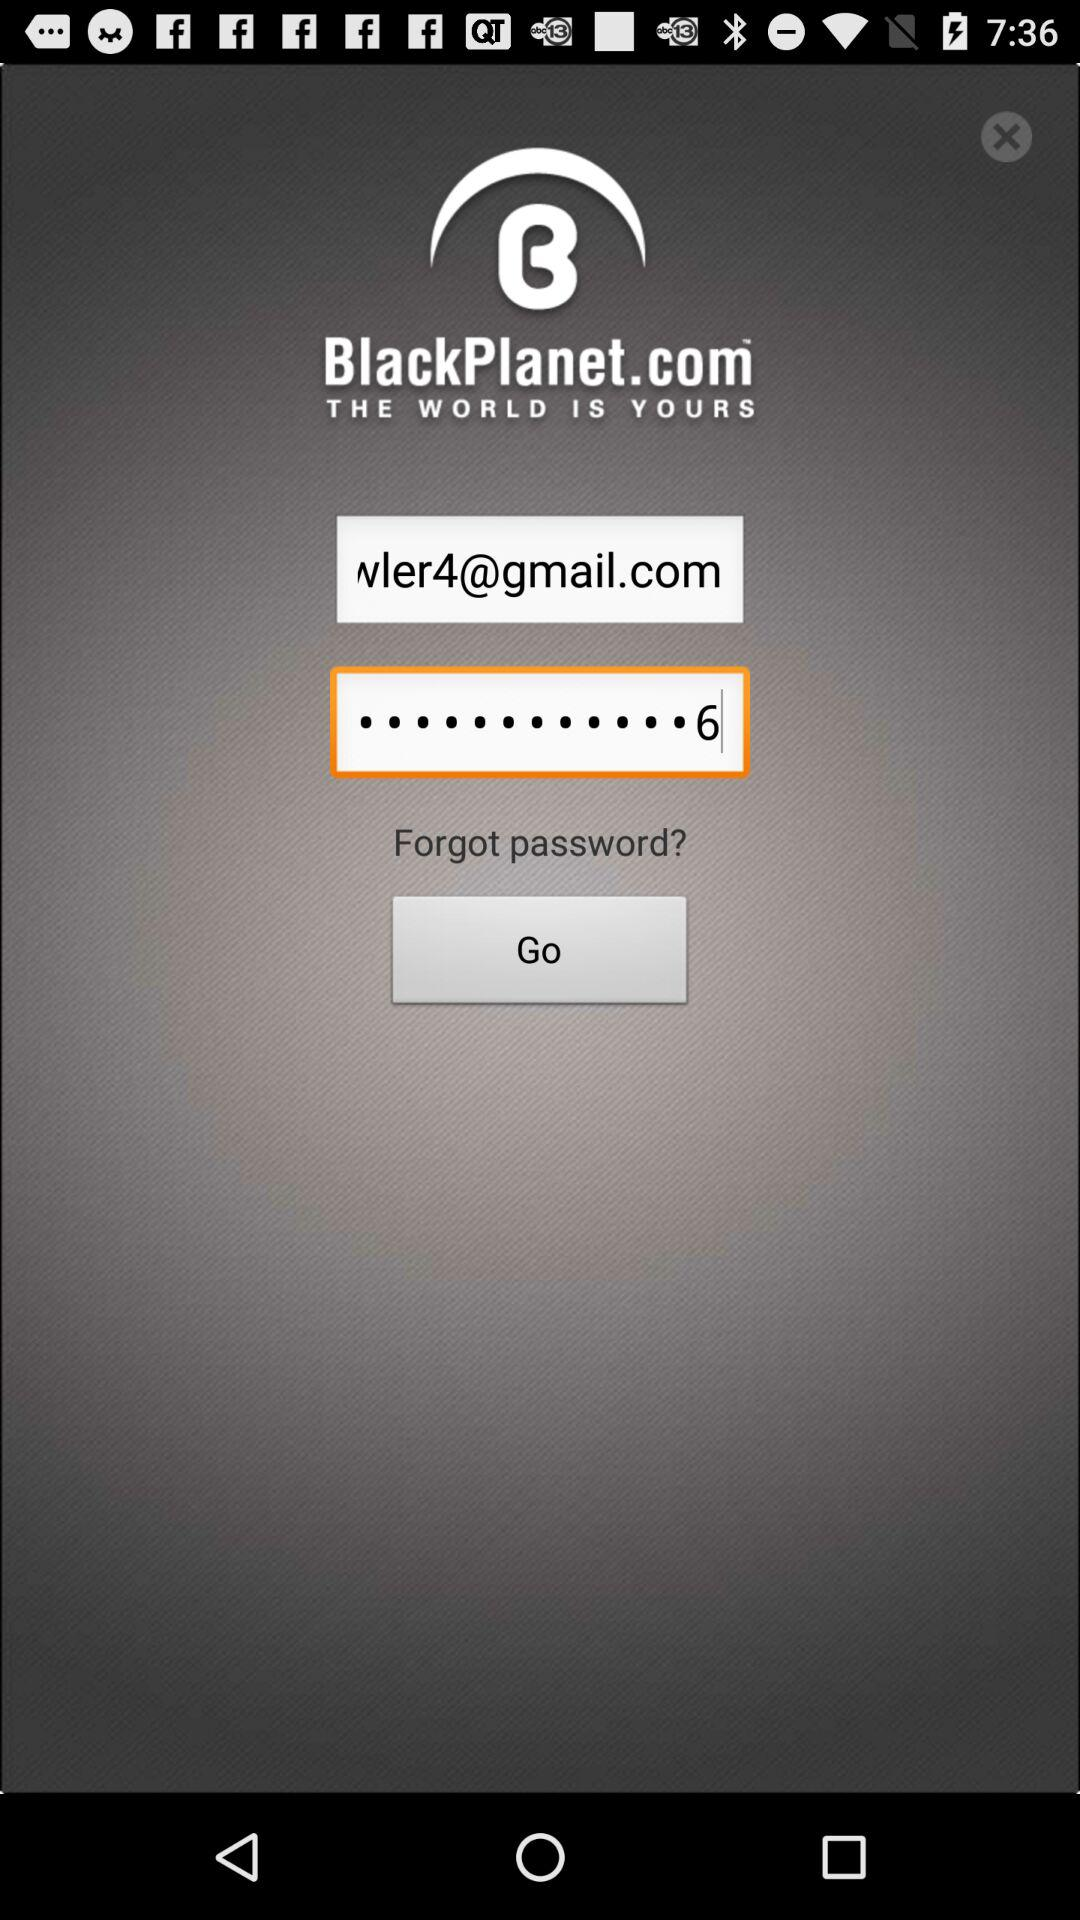What is the Email address?
When the provided information is insufficient, respond with <no answer>. <no answer> 